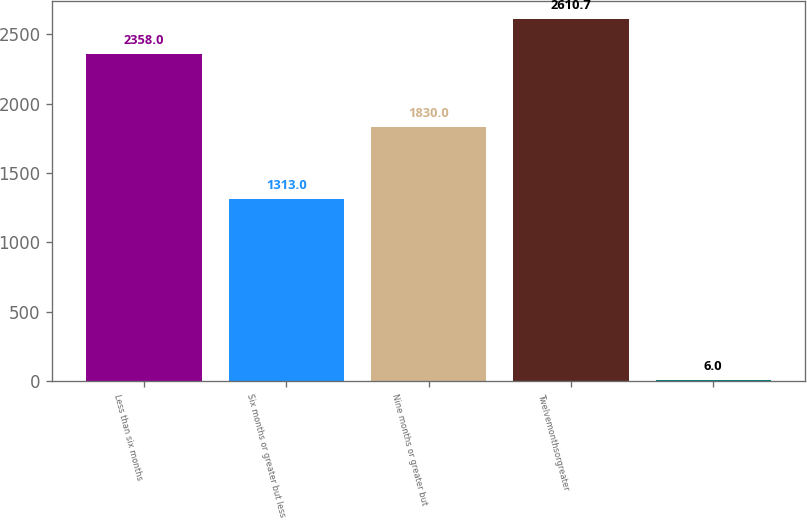Convert chart. <chart><loc_0><loc_0><loc_500><loc_500><bar_chart><fcel>Less than six months<fcel>Six months or greater but less<fcel>Nine months or greater but<fcel>Twelvemonthsorgreater<fcel>Unnamed: 4<nl><fcel>2358<fcel>1313<fcel>1830<fcel>2610.7<fcel>6<nl></chart> 